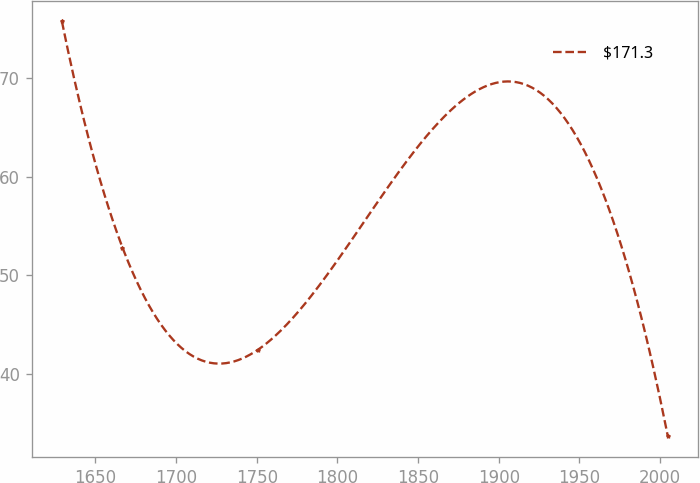Convert chart. <chart><loc_0><loc_0><loc_500><loc_500><line_chart><ecel><fcel>$171.3<nl><fcel>1629.19<fcel>75.72<nl><fcel>1666.75<fcel>52.83<nl><fcel>1750.83<fcel>42.5<nl><fcel>2004.79<fcel>33.71<nl></chart> 